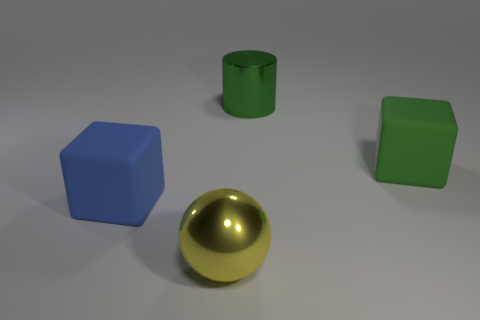The big cylinder has what color?
Make the answer very short. Green. Do the big rubber object left of the green cylinder and the cylinder have the same color?
Your answer should be very brief. No. There is another large matte object that is the same shape as the blue thing; what is its color?
Make the answer very short. Green. How many tiny things are either gray cubes or blue matte objects?
Ensure brevity in your answer.  0. There is a rubber thing that is behind the blue rubber block; what size is it?
Your answer should be very brief. Large. Is there a matte block of the same color as the large shiny cylinder?
Your answer should be compact. Yes. Is the sphere the same color as the metallic cylinder?
Your answer should be very brief. No. There is a object that is the same color as the big shiny cylinder; what is its shape?
Your answer should be very brief. Cube. There is a large rubber object to the right of the big yellow thing; what number of large green metallic things are in front of it?
Give a very brief answer. 0. What number of green cylinders are made of the same material as the large green cube?
Ensure brevity in your answer.  0. 